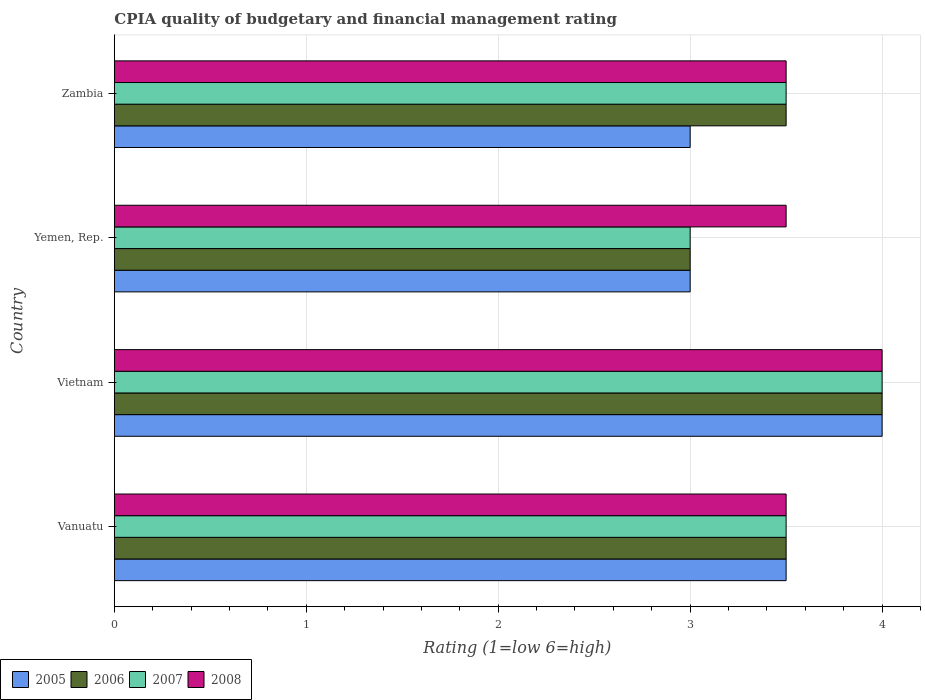How many different coloured bars are there?
Make the answer very short. 4. How many bars are there on the 4th tick from the top?
Offer a very short reply. 4. How many bars are there on the 1st tick from the bottom?
Provide a short and direct response. 4. What is the label of the 2nd group of bars from the top?
Provide a short and direct response. Yemen, Rep. What is the CPIA rating in 2005 in Vanuatu?
Offer a terse response. 3.5. Across all countries, what is the maximum CPIA rating in 2006?
Ensure brevity in your answer.  4. In which country was the CPIA rating in 2006 maximum?
Your response must be concise. Vietnam. In which country was the CPIA rating in 2005 minimum?
Make the answer very short. Yemen, Rep. What is the total CPIA rating in 2005 in the graph?
Your response must be concise. 13.5. In how many countries, is the CPIA rating in 2007 greater than 2.8 ?
Keep it short and to the point. 4. What is the ratio of the CPIA rating in 2007 in Vietnam to that in Zambia?
Your response must be concise. 1.14. Is the CPIA rating in 2008 in Vietnam less than that in Zambia?
Keep it short and to the point. No. Is the difference between the CPIA rating in 2006 in Vietnam and Yemen, Rep. greater than the difference between the CPIA rating in 2008 in Vietnam and Yemen, Rep.?
Your answer should be very brief. Yes. In how many countries, is the CPIA rating in 2006 greater than the average CPIA rating in 2006 taken over all countries?
Make the answer very short. 1. Is it the case that in every country, the sum of the CPIA rating in 2007 and CPIA rating in 2006 is greater than the CPIA rating in 2005?
Your response must be concise. Yes. How many bars are there?
Offer a very short reply. 16. Are all the bars in the graph horizontal?
Your response must be concise. Yes. How many countries are there in the graph?
Offer a terse response. 4. Does the graph contain grids?
Your answer should be very brief. Yes. How many legend labels are there?
Provide a short and direct response. 4. What is the title of the graph?
Keep it short and to the point. CPIA quality of budgetary and financial management rating. Does "2005" appear as one of the legend labels in the graph?
Make the answer very short. Yes. What is the Rating (1=low 6=high) of 2005 in Vanuatu?
Offer a very short reply. 3.5. What is the Rating (1=low 6=high) of 2006 in Vanuatu?
Offer a terse response. 3.5. What is the Rating (1=low 6=high) of 2005 in Vietnam?
Offer a very short reply. 4. What is the Rating (1=low 6=high) in 2006 in Vietnam?
Make the answer very short. 4. What is the Rating (1=low 6=high) of 2005 in Yemen, Rep.?
Offer a terse response. 3. What is the Rating (1=low 6=high) in 2006 in Yemen, Rep.?
Provide a succinct answer. 3. What is the Rating (1=low 6=high) of 2007 in Yemen, Rep.?
Provide a succinct answer. 3. What is the Rating (1=low 6=high) in 2007 in Zambia?
Your answer should be very brief. 3.5. Across all countries, what is the maximum Rating (1=low 6=high) in 2007?
Give a very brief answer. 4. Across all countries, what is the minimum Rating (1=low 6=high) of 2005?
Provide a succinct answer. 3. Across all countries, what is the minimum Rating (1=low 6=high) of 2008?
Your answer should be very brief. 3.5. What is the total Rating (1=low 6=high) in 2006 in the graph?
Offer a terse response. 14. What is the total Rating (1=low 6=high) of 2008 in the graph?
Give a very brief answer. 14.5. What is the difference between the Rating (1=low 6=high) of 2007 in Vanuatu and that in Vietnam?
Give a very brief answer. -0.5. What is the difference between the Rating (1=low 6=high) in 2005 in Vanuatu and that in Yemen, Rep.?
Your response must be concise. 0.5. What is the difference between the Rating (1=low 6=high) of 2007 in Vanuatu and that in Yemen, Rep.?
Your answer should be very brief. 0.5. What is the difference between the Rating (1=low 6=high) in 2005 in Vanuatu and that in Zambia?
Your answer should be very brief. 0.5. What is the difference between the Rating (1=low 6=high) of 2007 in Vanuatu and that in Zambia?
Your answer should be compact. 0. What is the difference between the Rating (1=low 6=high) of 2008 in Vanuatu and that in Zambia?
Your answer should be very brief. 0. What is the difference between the Rating (1=low 6=high) of 2008 in Vietnam and that in Yemen, Rep.?
Keep it short and to the point. 0.5. What is the difference between the Rating (1=low 6=high) in 2005 in Vietnam and that in Zambia?
Your response must be concise. 1. What is the difference between the Rating (1=low 6=high) of 2006 in Vietnam and that in Zambia?
Your response must be concise. 0.5. What is the difference between the Rating (1=low 6=high) of 2007 in Vietnam and that in Zambia?
Offer a terse response. 0.5. What is the difference between the Rating (1=low 6=high) in 2005 in Yemen, Rep. and that in Zambia?
Make the answer very short. 0. What is the difference between the Rating (1=low 6=high) of 2006 in Yemen, Rep. and that in Zambia?
Your answer should be very brief. -0.5. What is the difference between the Rating (1=low 6=high) in 2007 in Yemen, Rep. and that in Zambia?
Make the answer very short. -0.5. What is the difference between the Rating (1=low 6=high) of 2008 in Yemen, Rep. and that in Zambia?
Your response must be concise. 0. What is the difference between the Rating (1=low 6=high) of 2005 in Vanuatu and the Rating (1=low 6=high) of 2006 in Vietnam?
Your answer should be very brief. -0.5. What is the difference between the Rating (1=low 6=high) in 2006 in Vanuatu and the Rating (1=low 6=high) in 2008 in Vietnam?
Your response must be concise. -0.5. What is the difference between the Rating (1=low 6=high) of 2005 in Vanuatu and the Rating (1=low 6=high) of 2006 in Yemen, Rep.?
Provide a succinct answer. 0.5. What is the difference between the Rating (1=low 6=high) of 2005 in Vanuatu and the Rating (1=low 6=high) of 2007 in Yemen, Rep.?
Provide a short and direct response. 0.5. What is the difference between the Rating (1=low 6=high) in 2005 in Vanuatu and the Rating (1=low 6=high) in 2008 in Yemen, Rep.?
Offer a very short reply. 0. What is the difference between the Rating (1=low 6=high) in 2007 in Vanuatu and the Rating (1=low 6=high) in 2008 in Yemen, Rep.?
Make the answer very short. 0. What is the difference between the Rating (1=low 6=high) in 2005 in Vanuatu and the Rating (1=low 6=high) in 2007 in Zambia?
Offer a terse response. 0. What is the difference between the Rating (1=low 6=high) of 2006 in Vanuatu and the Rating (1=low 6=high) of 2007 in Zambia?
Give a very brief answer. 0. What is the difference between the Rating (1=low 6=high) in 2005 in Vietnam and the Rating (1=low 6=high) in 2006 in Yemen, Rep.?
Provide a short and direct response. 1. What is the difference between the Rating (1=low 6=high) of 2006 in Vietnam and the Rating (1=low 6=high) of 2007 in Yemen, Rep.?
Your response must be concise. 1. What is the difference between the Rating (1=low 6=high) in 2007 in Vietnam and the Rating (1=low 6=high) in 2008 in Yemen, Rep.?
Provide a short and direct response. 0.5. What is the difference between the Rating (1=low 6=high) in 2005 in Vietnam and the Rating (1=low 6=high) in 2006 in Zambia?
Your answer should be compact. 0.5. What is the difference between the Rating (1=low 6=high) in 2006 in Vietnam and the Rating (1=low 6=high) in 2007 in Zambia?
Provide a succinct answer. 0.5. What is the difference between the Rating (1=low 6=high) in 2006 in Vietnam and the Rating (1=low 6=high) in 2008 in Zambia?
Keep it short and to the point. 0.5. What is the difference between the Rating (1=low 6=high) of 2005 in Yemen, Rep. and the Rating (1=low 6=high) of 2006 in Zambia?
Provide a succinct answer. -0.5. What is the difference between the Rating (1=low 6=high) of 2005 in Yemen, Rep. and the Rating (1=low 6=high) of 2008 in Zambia?
Your answer should be very brief. -0.5. What is the difference between the Rating (1=low 6=high) of 2006 in Yemen, Rep. and the Rating (1=low 6=high) of 2007 in Zambia?
Keep it short and to the point. -0.5. What is the difference between the Rating (1=low 6=high) of 2007 in Yemen, Rep. and the Rating (1=low 6=high) of 2008 in Zambia?
Make the answer very short. -0.5. What is the average Rating (1=low 6=high) of 2005 per country?
Make the answer very short. 3.38. What is the average Rating (1=low 6=high) in 2006 per country?
Offer a very short reply. 3.5. What is the average Rating (1=low 6=high) of 2007 per country?
Make the answer very short. 3.5. What is the average Rating (1=low 6=high) in 2008 per country?
Make the answer very short. 3.62. What is the difference between the Rating (1=low 6=high) of 2005 and Rating (1=low 6=high) of 2008 in Vanuatu?
Your response must be concise. 0. What is the difference between the Rating (1=low 6=high) of 2007 and Rating (1=low 6=high) of 2008 in Vanuatu?
Make the answer very short. 0. What is the difference between the Rating (1=low 6=high) of 2005 and Rating (1=low 6=high) of 2007 in Vietnam?
Ensure brevity in your answer.  0. What is the difference between the Rating (1=low 6=high) of 2006 and Rating (1=low 6=high) of 2007 in Vietnam?
Make the answer very short. 0. What is the difference between the Rating (1=low 6=high) of 2006 and Rating (1=low 6=high) of 2008 in Vietnam?
Ensure brevity in your answer.  0. What is the difference between the Rating (1=low 6=high) in 2007 and Rating (1=low 6=high) in 2008 in Vietnam?
Ensure brevity in your answer.  0. What is the difference between the Rating (1=low 6=high) of 2005 and Rating (1=low 6=high) of 2006 in Yemen, Rep.?
Your response must be concise. 0. What is the difference between the Rating (1=low 6=high) of 2005 and Rating (1=low 6=high) of 2008 in Yemen, Rep.?
Your answer should be very brief. -0.5. What is the difference between the Rating (1=low 6=high) in 2006 and Rating (1=low 6=high) in 2007 in Yemen, Rep.?
Your answer should be compact. 0. What is the difference between the Rating (1=low 6=high) of 2006 and Rating (1=low 6=high) of 2008 in Yemen, Rep.?
Your answer should be compact. -0.5. What is the difference between the Rating (1=low 6=high) of 2005 and Rating (1=low 6=high) of 2007 in Zambia?
Your answer should be compact. -0.5. What is the ratio of the Rating (1=low 6=high) in 2005 in Vanuatu to that in Vietnam?
Make the answer very short. 0.88. What is the ratio of the Rating (1=low 6=high) of 2008 in Vanuatu to that in Vietnam?
Keep it short and to the point. 0.88. What is the ratio of the Rating (1=low 6=high) in 2006 in Vanuatu to that in Yemen, Rep.?
Offer a very short reply. 1.17. What is the ratio of the Rating (1=low 6=high) of 2007 in Vanuatu to that in Yemen, Rep.?
Your answer should be compact. 1.17. What is the ratio of the Rating (1=low 6=high) in 2007 in Vanuatu to that in Zambia?
Give a very brief answer. 1. What is the ratio of the Rating (1=low 6=high) of 2005 in Vietnam to that in Yemen, Rep.?
Your answer should be compact. 1.33. What is the ratio of the Rating (1=low 6=high) in 2006 in Vietnam to that in Yemen, Rep.?
Your answer should be compact. 1.33. What is the ratio of the Rating (1=low 6=high) in 2008 in Vietnam to that in Yemen, Rep.?
Your answer should be very brief. 1.14. What is the ratio of the Rating (1=low 6=high) in 2005 in Vietnam to that in Zambia?
Provide a short and direct response. 1.33. What is the ratio of the Rating (1=low 6=high) in 2006 in Vietnam to that in Zambia?
Offer a terse response. 1.14. What is the ratio of the Rating (1=low 6=high) in 2008 in Vietnam to that in Zambia?
Offer a very short reply. 1.14. What is the ratio of the Rating (1=low 6=high) of 2007 in Yemen, Rep. to that in Zambia?
Make the answer very short. 0.86. What is the ratio of the Rating (1=low 6=high) in 2008 in Yemen, Rep. to that in Zambia?
Give a very brief answer. 1. What is the difference between the highest and the second highest Rating (1=low 6=high) of 2005?
Your response must be concise. 0.5. What is the difference between the highest and the second highest Rating (1=low 6=high) in 2007?
Your response must be concise. 0.5. What is the difference between the highest and the lowest Rating (1=low 6=high) of 2006?
Provide a succinct answer. 1. What is the difference between the highest and the lowest Rating (1=low 6=high) of 2007?
Your answer should be very brief. 1. 